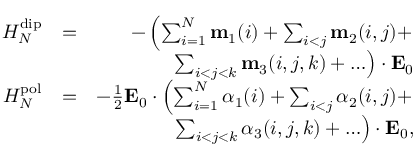Convert formula to latex. <formula><loc_0><loc_0><loc_500><loc_500>\begin{array} { r l r } { H _ { N } ^ { d i p } } & { = } & { - \left ( \sum _ { i = 1 } ^ { N } m _ { 1 } ( i ) + \sum _ { i < j } m _ { 2 } ( i , j ) + } \\ & { \sum _ { i < j < k } m _ { 3 } ( i , j , k ) + \dots \right ) \cdot E _ { 0 } } \\ { H _ { N } ^ { p o l } } & { = } & { - \frac { 1 } { 2 } E _ { 0 } \cdot \left ( \sum _ { i = 1 } ^ { N } \alpha _ { 1 } ( i ) + \sum _ { i < j } \alpha _ { 2 } ( i , j ) + } \\ & { \sum _ { i < j < k } \alpha _ { 3 } ( i , j , k ) + \dots \right ) \cdot E _ { 0 } , } \end{array}</formula> 